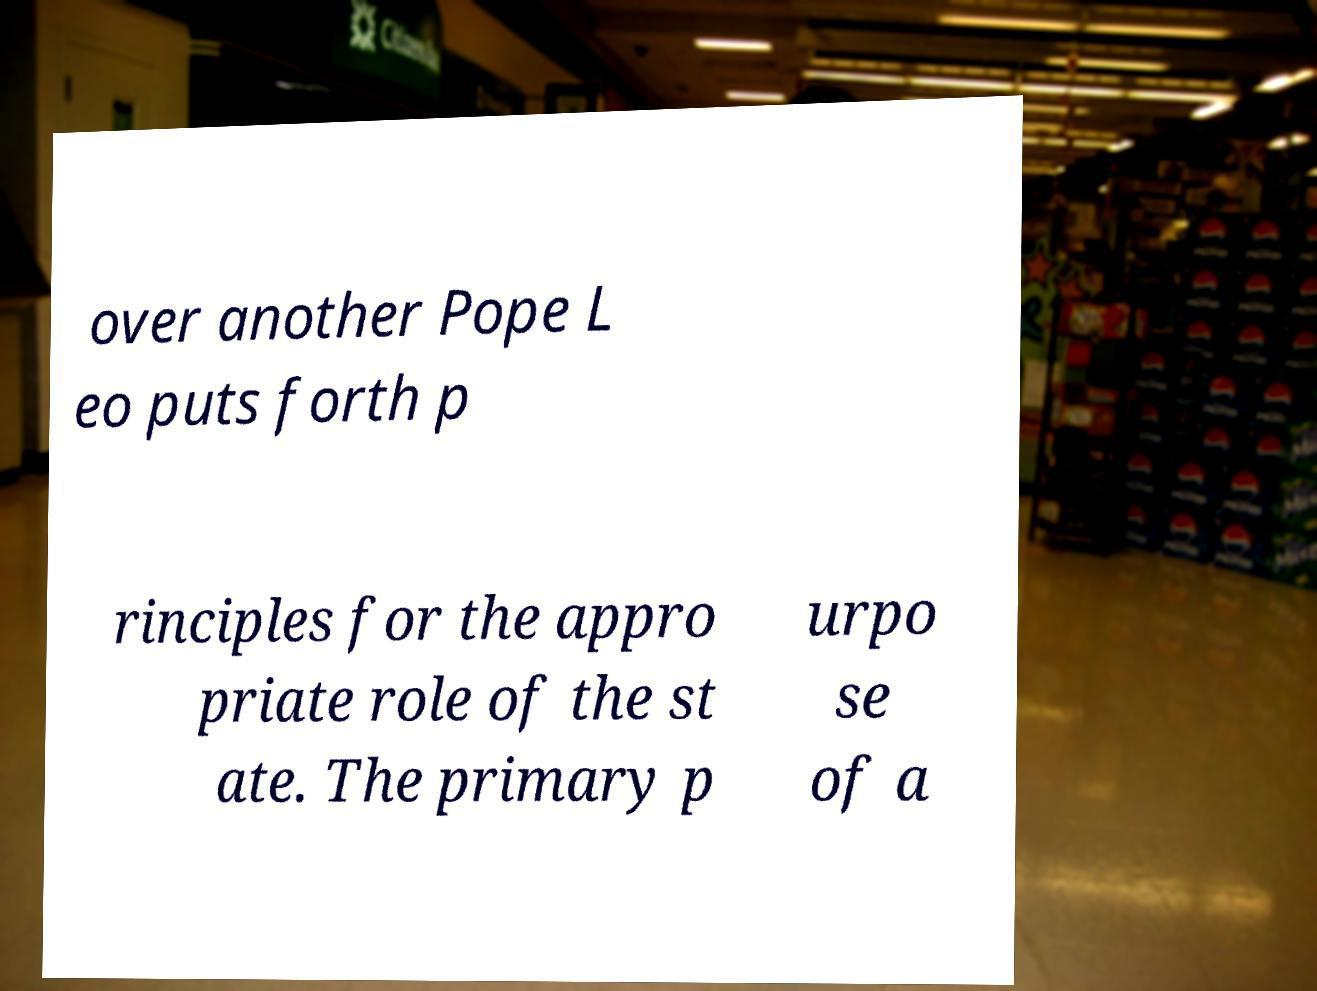I need the written content from this picture converted into text. Can you do that? over another Pope L eo puts forth p rinciples for the appro priate role of the st ate. The primary p urpo se of a 